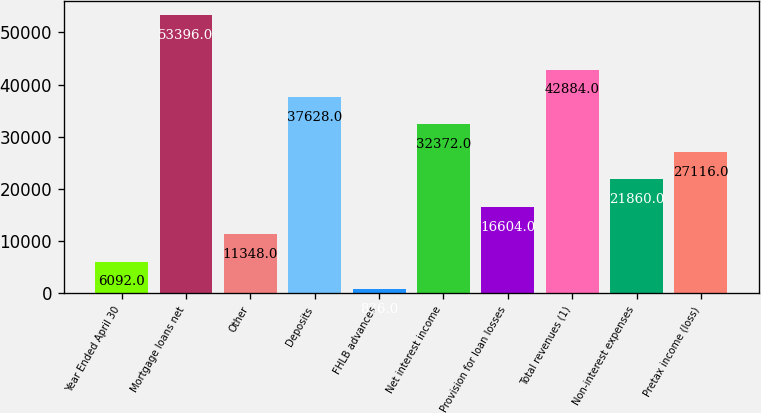Convert chart to OTSL. <chart><loc_0><loc_0><loc_500><loc_500><bar_chart><fcel>Year Ended April 30<fcel>Mortgage loans net<fcel>Other<fcel>Deposits<fcel>FHLB advances<fcel>Net interest income<fcel>Provision for loan losses<fcel>Total revenues (1)<fcel>Non-interest expenses<fcel>Pretax income (loss)<nl><fcel>6092<fcel>53396<fcel>11348<fcel>37628<fcel>836<fcel>32372<fcel>16604<fcel>42884<fcel>21860<fcel>27116<nl></chart> 